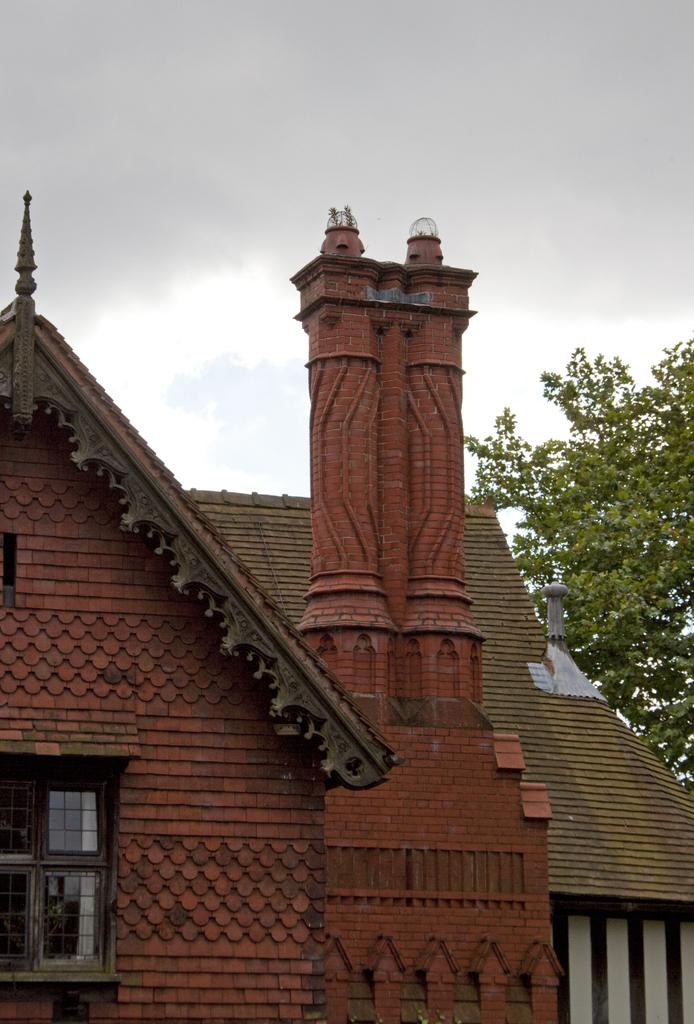What is the main structure in the middle of the image? There is a house in the middle of the image. What type of vegetation is on the right side of the image? There is a tree on the right side of the image. What is visible at the top of the image? The sky is visible at the top of the image. Where is the window located in the image? There is a window on the left side of the image, near the bottom. What type of alarm can be heard going off in the image? There is no alarm present in the image, and therefore no such sound can be heard. 